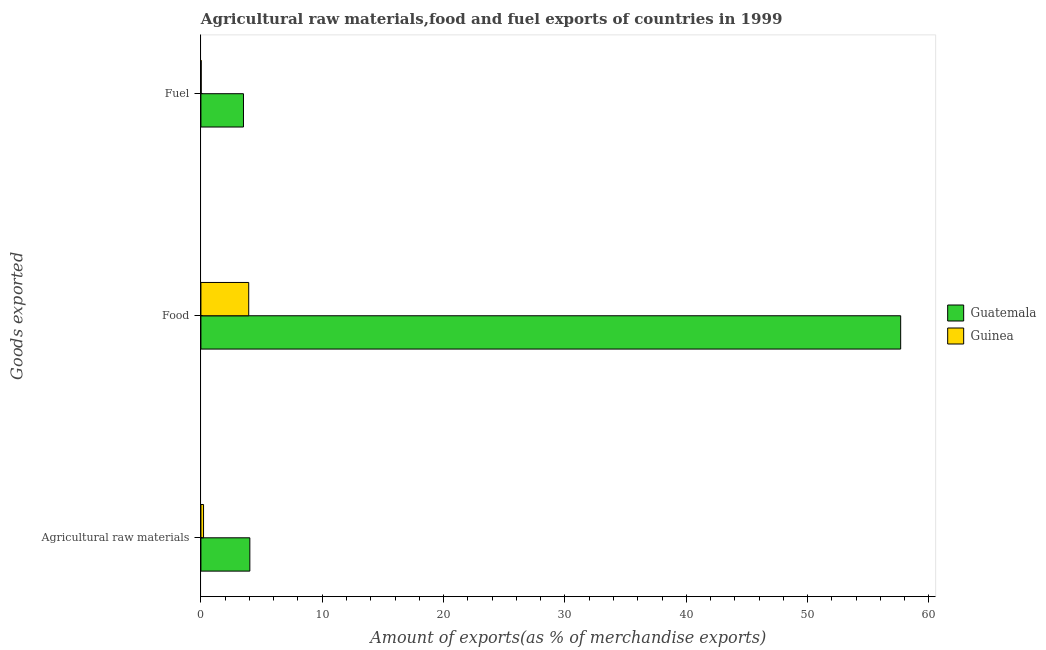How many different coloured bars are there?
Provide a short and direct response. 2. How many groups of bars are there?
Provide a short and direct response. 3. Are the number of bars on each tick of the Y-axis equal?
Make the answer very short. Yes. How many bars are there on the 1st tick from the top?
Provide a succinct answer. 2. How many bars are there on the 2nd tick from the bottom?
Ensure brevity in your answer.  2. What is the label of the 3rd group of bars from the top?
Provide a short and direct response. Agricultural raw materials. What is the percentage of raw materials exports in Guinea?
Ensure brevity in your answer.  0.22. Across all countries, what is the maximum percentage of fuel exports?
Your answer should be compact. 3.51. Across all countries, what is the minimum percentage of raw materials exports?
Your response must be concise. 0.22. In which country was the percentage of raw materials exports maximum?
Your answer should be very brief. Guatemala. In which country was the percentage of raw materials exports minimum?
Provide a short and direct response. Guinea. What is the total percentage of food exports in the graph?
Provide a short and direct response. 61.61. What is the difference between the percentage of fuel exports in Guinea and that in Guatemala?
Offer a very short reply. -3.48. What is the difference between the percentage of food exports in Guatemala and the percentage of raw materials exports in Guinea?
Your answer should be compact. 57.45. What is the average percentage of fuel exports per country?
Your answer should be compact. 1.76. What is the difference between the percentage of food exports and percentage of raw materials exports in Guatemala?
Your answer should be very brief. 53.64. In how many countries, is the percentage of raw materials exports greater than 12 %?
Keep it short and to the point. 0. What is the ratio of the percentage of fuel exports in Guinea to that in Guatemala?
Ensure brevity in your answer.  0.01. Is the difference between the percentage of fuel exports in Guatemala and Guinea greater than the difference between the percentage of food exports in Guatemala and Guinea?
Ensure brevity in your answer.  No. What is the difference between the highest and the second highest percentage of fuel exports?
Keep it short and to the point. 3.48. What is the difference between the highest and the lowest percentage of raw materials exports?
Your response must be concise. 3.82. In how many countries, is the percentage of fuel exports greater than the average percentage of fuel exports taken over all countries?
Offer a terse response. 1. What does the 1st bar from the top in Agricultural raw materials represents?
Provide a succinct answer. Guinea. What does the 2nd bar from the bottom in Fuel represents?
Your answer should be compact. Guinea. Are all the bars in the graph horizontal?
Offer a terse response. Yes. Does the graph contain any zero values?
Make the answer very short. No. Does the graph contain grids?
Ensure brevity in your answer.  No. Where does the legend appear in the graph?
Offer a very short reply. Center right. How are the legend labels stacked?
Ensure brevity in your answer.  Vertical. What is the title of the graph?
Make the answer very short. Agricultural raw materials,food and fuel exports of countries in 1999. What is the label or title of the X-axis?
Offer a very short reply. Amount of exports(as % of merchandise exports). What is the label or title of the Y-axis?
Your answer should be compact. Goods exported. What is the Amount of exports(as % of merchandise exports) in Guatemala in Agricultural raw materials?
Keep it short and to the point. 4.03. What is the Amount of exports(as % of merchandise exports) in Guinea in Agricultural raw materials?
Offer a terse response. 0.22. What is the Amount of exports(as % of merchandise exports) of Guatemala in Food?
Offer a very short reply. 57.67. What is the Amount of exports(as % of merchandise exports) in Guinea in Food?
Provide a succinct answer. 3.94. What is the Amount of exports(as % of merchandise exports) of Guatemala in Fuel?
Offer a very short reply. 3.51. What is the Amount of exports(as % of merchandise exports) in Guinea in Fuel?
Your answer should be very brief. 0.02. Across all Goods exported, what is the maximum Amount of exports(as % of merchandise exports) of Guatemala?
Keep it short and to the point. 57.67. Across all Goods exported, what is the maximum Amount of exports(as % of merchandise exports) in Guinea?
Offer a very short reply. 3.94. Across all Goods exported, what is the minimum Amount of exports(as % of merchandise exports) of Guatemala?
Provide a short and direct response. 3.51. Across all Goods exported, what is the minimum Amount of exports(as % of merchandise exports) in Guinea?
Keep it short and to the point. 0.02. What is the total Amount of exports(as % of merchandise exports) in Guatemala in the graph?
Your response must be concise. 65.21. What is the total Amount of exports(as % of merchandise exports) in Guinea in the graph?
Provide a short and direct response. 4.18. What is the difference between the Amount of exports(as % of merchandise exports) of Guatemala in Agricultural raw materials and that in Food?
Your answer should be compact. -53.64. What is the difference between the Amount of exports(as % of merchandise exports) in Guinea in Agricultural raw materials and that in Food?
Give a very brief answer. -3.72. What is the difference between the Amount of exports(as % of merchandise exports) of Guatemala in Agricultural raw materials and that in Fuel?
Your answer should be very brief. 0.53. What is the difference between the Amount of exports(as % of merchandise exports) in Guinea in Agricultural raw materials and that in Fuel?
Offer a very short reply. 0.19. What is the difference between the Amount of exports(as % of merchandise exports) of Guatemala in Food and that in Fuel?
Your answer should be compact. 54.16. What is the difference between the Amount of exports(as % of merchandise exports) in Guinea in Food and that in Fuel?
Make the answer very short. 3.92. What is the difference between the Amount of exports(as % of merchandise exports) of Guatemala in Agricultural raw materials and the Amount of exports(as % of merchandise exports) of Guinea in Food?
Ensure brevity in your answer.  0.09. What is the difference between the Amount of exports(as % of merchandise exports) of Guatemala in Agricultural raw materials and the Amount of exports(as % of merchandise exports) of Guinea in Fuel?
Give a very brief answer. 4.01. What is the difference between the Amount of exports(as % of merchandise exports) in Guatemala in Food and the Amount of exports(as % of merchandise exports) in Guinea in Fuel?
Your answer should be very brief. 57.65. What is the average Amount of exports(as % of merchandise exports) of Guatemala per Goods exported?
Offer a terse response. 21.74. What is the average Amount of exports(as % of merchandise exports) of Guinea per Goods exported?
Provide a short and direct response. 1.39. What is the difference between the Amount of exports(as % of merchandise exports) of Guatemala and Amount of exports(as % of merchandise exports) of Guinea in Agricultural raw materials?
Offer a terse response. 3.82. What is the difference between the Amount of exports(as % of merchandise exports) of Guatemala and Amount of exports(as % of merchandise exports) of Guinea in Food?
Your answer should be compact. 53.73. What is the difference between the Amount of exports(as % of merchandise exports) of Guatemala and Amount of exports(as % of merchandise exports) of Guinea in Fuel?
Offer a terse response. 3.48. What is the ratio of the Amount of exports(as % of merchandise exports) in Guatemala in Agricultural raw materials to that in Food?
Ensure brevity in your answer.  0.07. What is the ratio of the Amount of exports(as % of merchandise exports) of Guinea in Agricultural raw materials to that in Food?
Offer a very short reply. 0.06. What is the ratio of the Amount of exports(as % of merchandise exports) in Guatemala in Agricultural raw materials to that in Fuel?
Make the answer very short. 1.15. What is the ratio of the Amount of exports(as % of merchandise exports) in Guinea in Agricultural raw materials to that in Fuel?
Your answer should be compact. 9.66. What is the ratio of the Amount of exports(as % of merchandise exports) of Guatemala in Food to that in Fuel?
Your response must be concise. 16.45. What is the ratio of the Amount of exports(as % of merchandise exports) of Guinea in Food to that in Fuel?
Your response must be concise. 175.01. What is the difference between the highest and the second highest Amount of exports(as % of merchandise exports) in Guatemala?
Keep it short and to the point. 53.64. What is the difference between the highest and the second highest Amount of exports(as % of merchandise exports) of Guinea?
Keep it short and to the point. 3.72. What is the difference between the highest and the lowest Amount of exports(as % of merchandise exports) in Guatemala?
Offer a very short reply. 54.16. What is the difference between the highest and the lowest Amount of exports(as % of merchandise exports) of Guinea?
Make the answer very short. 3.92. 